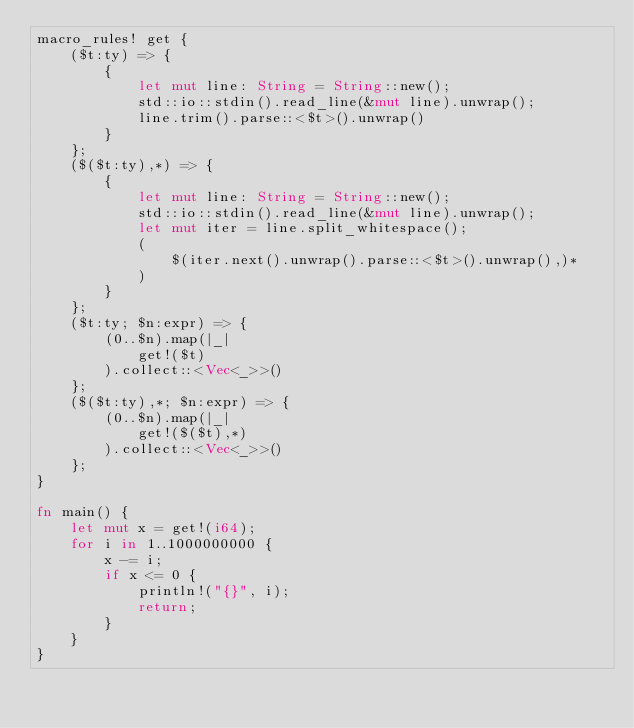Convert code to text. <code><loc_0><loc_0><loc_500><loc_500><_Rust_>macro_rules! get {
    ($t:ty) => {
        {
            let mut line: String = String::new();
            std::io::stdin().read_line(&mut line).unwrap();
            line.trim().parse::<$t>().unwrap()
        }
    };
    ($($t:ty),*) => {
        {
            let mut line: String = String::new();
            std::io::stdin().read_line(&mut line).unwrap();
            let mut iter = line.split_whitespace();
            (
                $(iter.next().unwrap().parse::<$t>().unwrap(),)*
            )
        }
    };
    ($t:ty; $n:expr) => {
        (0..$n).map(|_|
            get!($t)
        ).collect::<Vec<_>>()
    };
    ($($t:ty),*; $n:expr) => {
        (0..$n).map(|_|
            get!($($t),*)
        ).collect::<Vec<_>>()
    };
}

fn main() {
    let mut x = get!(i64);
    for i in 1..1000000000 {
        x -= i;
        if x <= 0 {
            println!("{}", i);
            return;
        }
    }
}</code> 